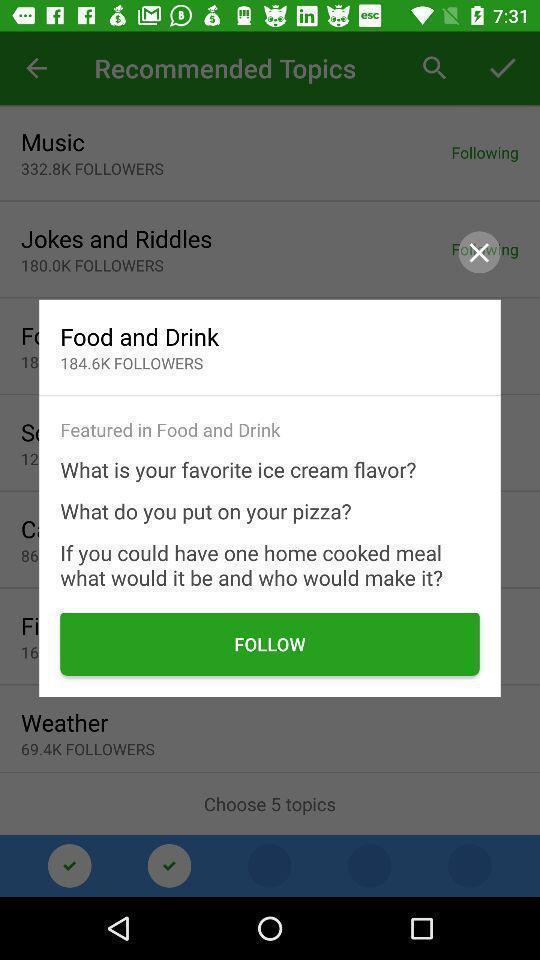Describe the content in this image. Popup showing option to follow. 